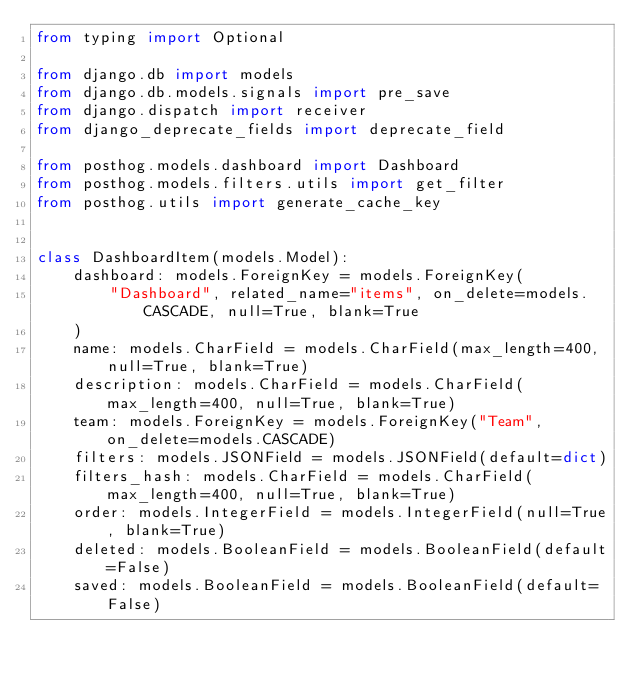<code> <loc_0><loc_0><loc_500><loc_500><_Python_>from typing import Optional

from django.db import models
from django.db.models.signals import pre_save
from django.dispatch import receiver
from django_deprecate_fields import deprecate_field

from posthog.models.dashboard import Dashboard
from posthog.models.filters.utils import get_filter
from posthog.utils import generate_cache_key


class DashboardItem(models.Model):
    dashboard: models.ForeignKey = models.ForeignKey(
        "Dashboard", related_name="items", on_delete=models.CASCADE, null=True, blank=True
    )
    name: models.CharField = models.CharField(max_length=400, null=True, blank=True)
    description: models.CharField = models.CharField(max_length=400, null=True, blank=True)
    team: models.ForeignKey = models.ForeignKey("Team", on_delete=models.CASCADE)
    filters: models.JSONField = models.JSONField(default=dict)
    filters_hash: models.CharField = models.CharField(max_length=400, null=True, blank=True)
    order: models.IntegerField = models.IntegerField(null=True, blank=True)
    deleted: models.BooleanField = models.BooleanField(default=False)
    saved: models.BooleanField = models.BooleanField(default=False)</code> 